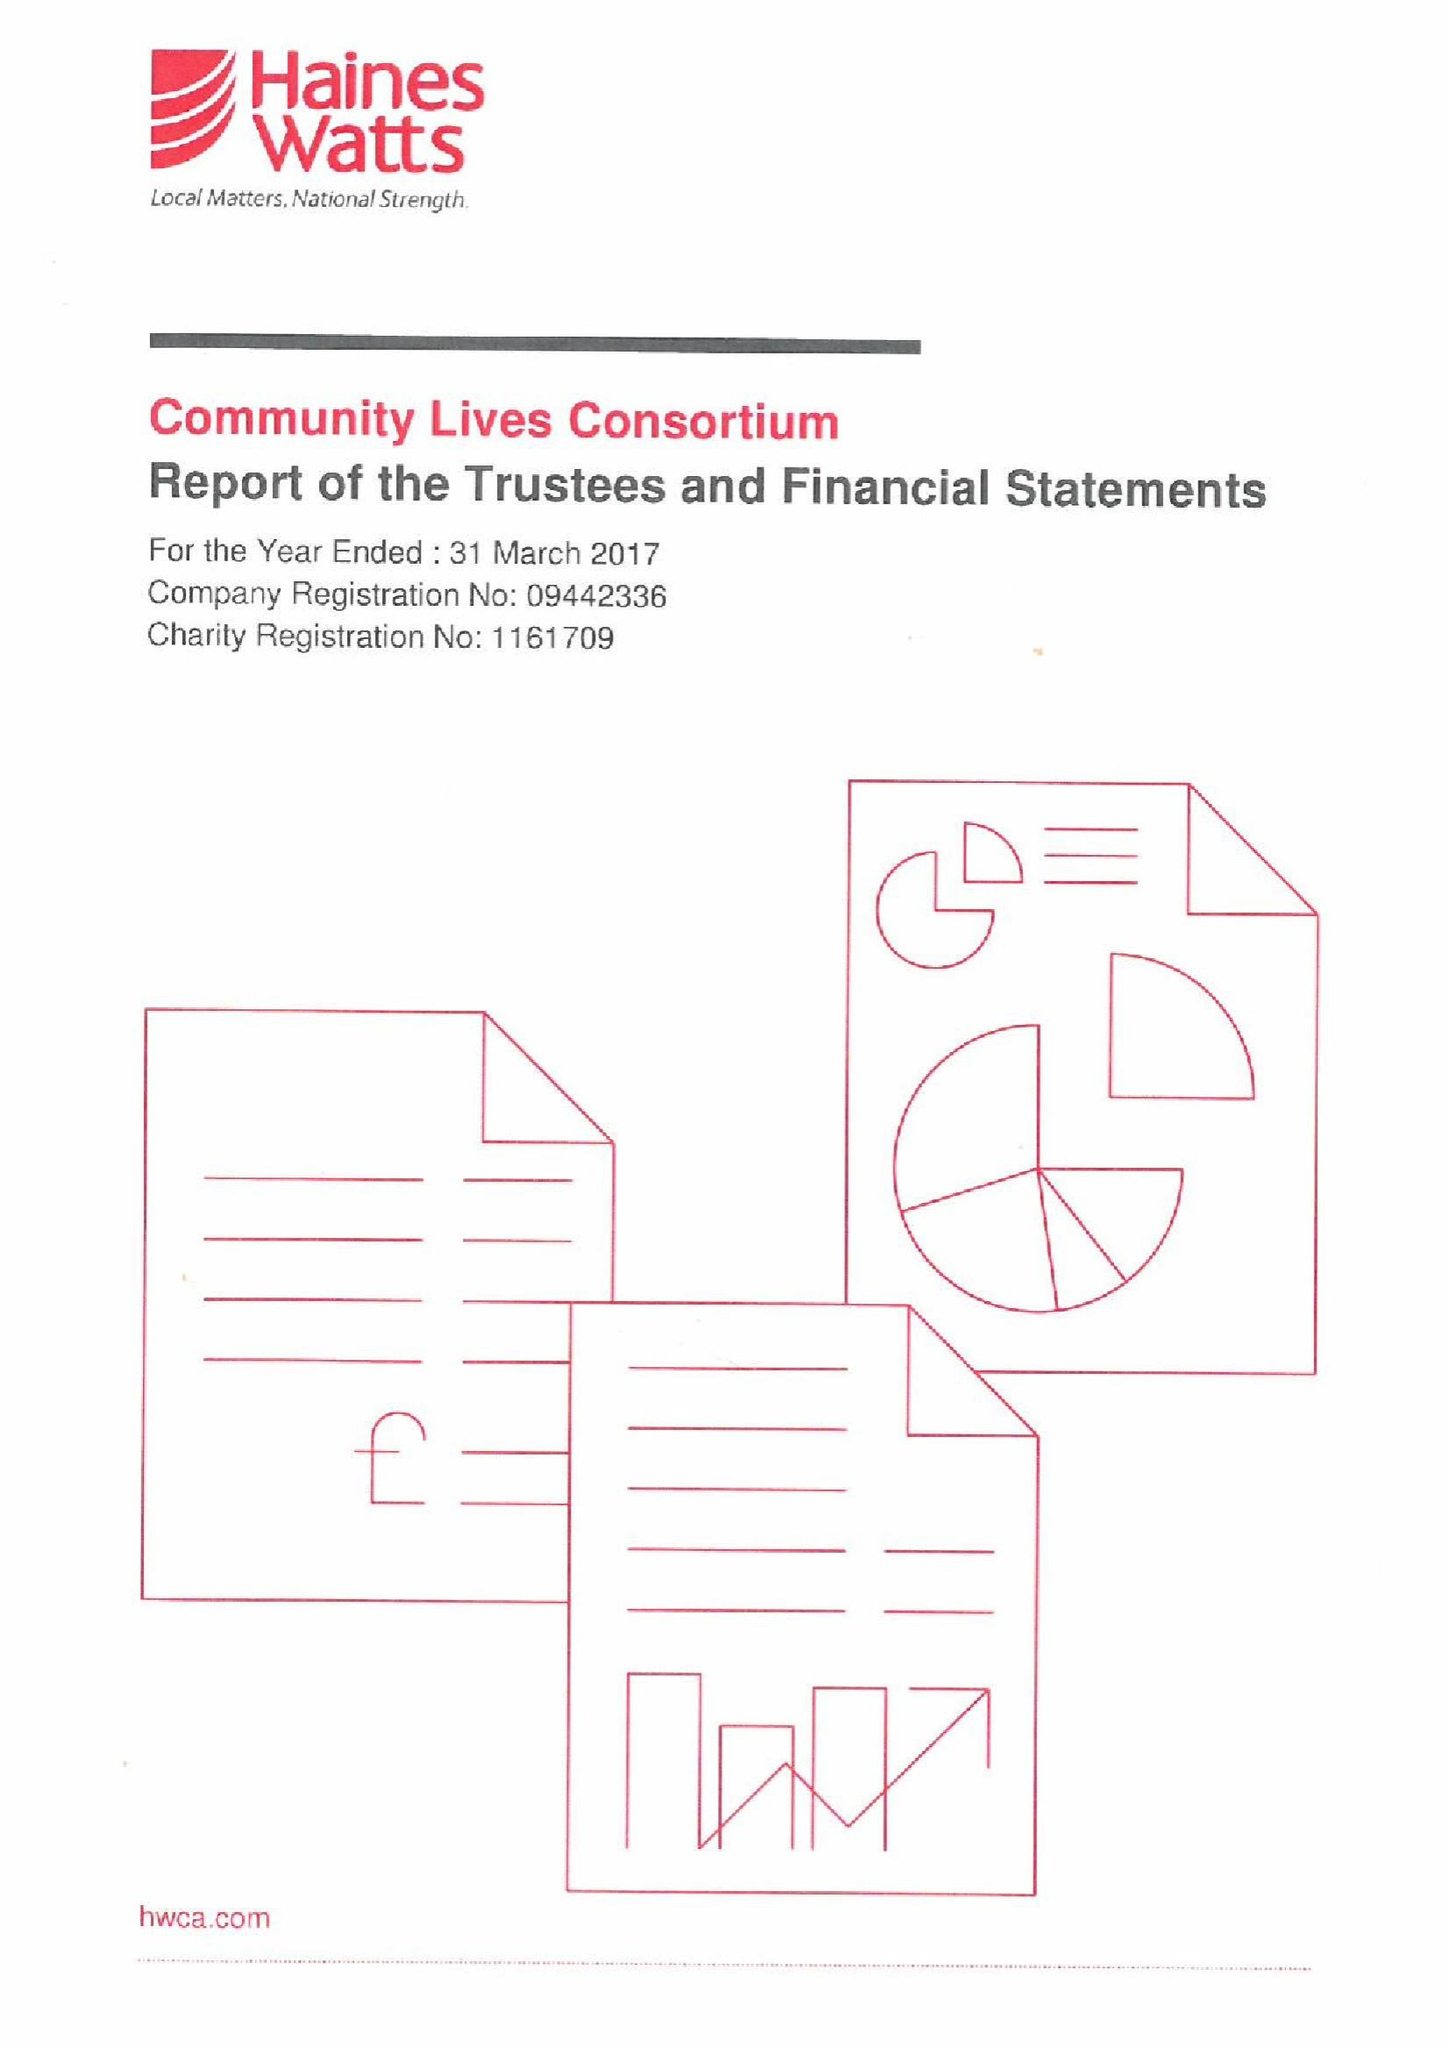What is the value for the spending_annually_in_british_pounds?
Answer the question using a single word or phrase. 15714070.00 